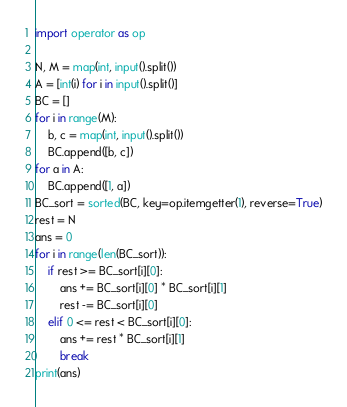<code> <loc_0><loc_0><loc_500><loc_500><_Python_>import operator as op

N, M = map(int, input().split())
A = [int(i) for i in input().split()]
BC = []
for i in range(M):
    b, c = map(int, input().split())
    BC.append([b, c])
for a in A:
    BC.append([1, a])
BC_sort = sorted(BC, key=op.itemgetter(1), reverse=True)
rest = N
ans = 0
for i in range(len(BC_sort)):
    if rest >= BC_sort[i][0]:
        ans += BC_sort[i][0] * BC_sort[i][1]
        rest -= BC_sort[i][0]
    elif 0 <= rest < BC_sort[i][0]:
        ans += rest * BC_sort[i][1]
        break
print(ans)
</code> 